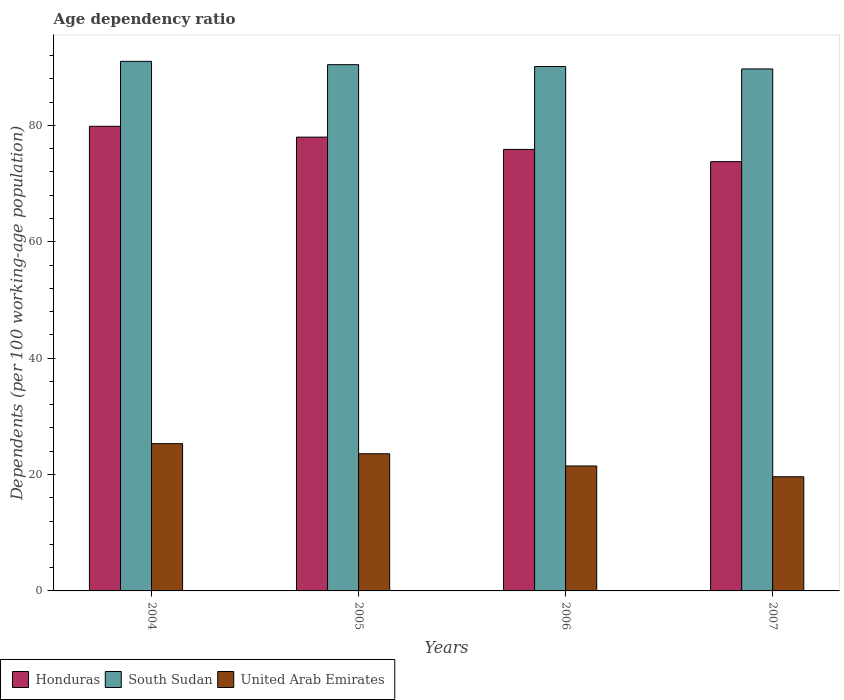How many different coloured bars are there?
Make the answer very short. 3. How many groups of bars are there?
Your answer should be compact. 4. Are the number of bars per tick equal to the number of legend labels?
Your answer should be very brief. Yes. How many bars are there on the 2nd tick from the right?
Keep it short and to the point. 3. What is the age dependency ratio in in Honduras in 2004?
Offer a terse response. 79.83. Across all years, what is the maximum age dependency ratio in in United Arab Emirates?
Ensure brevity in your answer.  25.3. Across all years, what is the minimum age dependency ratio in in South Sudan?
Your answer should be very brief. 89.69. In which year was the age dependency ratio in in Honduras minimum?
Offer a terse response. 2007. What is the total age dependency ratio in in Honduras in the graph?
Your answer should be compact. 307.42. What is the difference between the age dependency ratio in in South Sudan in 2004 and that in 2006?
Your answer should be very brief. 0.89. What is the difference between the age dependency ratio in in South Sudan in 2006 and the age dependency ratio in in United Arab Emirates in 2004?
Provide a succinct answer. 64.8. What is the average age dependency ratio in in United Arab Emirates per year?
Offer a very short reply. 22.49. In the year 2005, what is the difference between the age dependency ratio in in South Sudan and age dependency ratio in in United Arab Emirates?
Keep it short and to the point. 66.86. In how many years, is the age dependency ratio in in United Arab Emirates greater than 44 %?
Offer a very short reply. 0. What is the ratio of the age dependency ratio in in Honduras in 2006 to that in 2007?
Give a very brief answer. 1.03. Is the difference between the age dependency ratio in in South Sudan in 2005 and 2007 greater than the difference between the age dependency ratio in in United Arab Emirates in 2005 and 2007?
Provide a succinct answer. No. What is the difference between the highest and the second highest age dependency ratio in in United Arab Emirates?
Give a very brief answer. 1.74. What is the difference between the highest and the lowest age dependency ratio in in South Sudan?
Keep it short and to the point. 1.3. Is the sum of the age dependency ratio in in South Sudan in 2005 and 2006 greater than the maximum age dependency ratio in in Honduras across all years?
Your answer should be compact. Yes. What does the 3rd bar from the left in 2004 represents?
Provide a short and direct response. United Arab Emirates. What does the 3rd bar from the right in 2007 represents?
Provide a short and direct response. Honduras. How many bars are there?
Your answer should be very brief. 12. Are all the bars in the graph horizontal?
Offer a very short reply. No. Are the values on the major ticks of Y-axis written in scientific E-notation?
Give a very brief answer. No. Does the graph contain any zero values?
Offer a terse response. No. How are the legend labels stacked?
Ensure brevity in your answer.  Horizontal. What is the title of the graph?
Make the answer very short. Age dependency ratio. What is the label or title of the Y-axis?
Give a very brief answer. Dependents (per 100 working-age population). What is the Dependents (per 100 working-age population) in Honduras in 2004?
Your answer should be compact. 79.83. What is the Dependents (per 100 working-age population) in South Sudan in 2004?
Your answer should be very brief. 90.99. What is the Dependents (per 100 working-age population) in United Arab Emirates in 2004?
Provide a succinct answer. 25.3. What is the Dependents (per 100 working-age population) in Honduras in 2005?
Offer a very short reply. 77.97. What is the Dependents (per 100 working-age population) in South Sudan in 2005?
Offer a very short reply. 90.42. What is the Dependents (per 100 working-age population) of United Arab Emirates in 2005?
Provide a succinct answer. 23.57. What is the Dependents (per 100 working-age population) of Honduras in 2006?
Your answer should be compact. 75.86. What is the Dependents (per 100 working-age population) of South Sudan in 2006?
Offer a terse response. 90.1. What is the Dependents (per 100 working-age population) in United Arab Emirates in 2006?
Your answer should be compact. 21.47. What is the Dependents (per 100 working-age population) of Honduras in 2007?
Offer a very short reply. 73.75. What is the Dependents (per 100 working-age population) in South Sudan in 2007?
Offer a very short reply. 89.69. What is the Dependents (per 100 working-age population) in United Arab Emirates in 2007?
Offer a terse response. 19.61. Across all years, what is the maximum Dependents (per 100 working-age population) of Honduras?
Offer a terse response. 79.83. Across all years, what is the maximum Dependents (per 100 working-age population) in South Sudan?
Make the answer very short. 90.99. Across all years, what is the maximum Dependents (per 100 working-age population) of United Arab Emirates?
Offer a terse response. 25.3. Across all years, what is the minimum Dependents (per 100 working-age population) in Honduras?
Your answer should be compact. 73.75. Across all years, what is the minimum Dependents (per 100 working-age population) of South Sudan?
Provide a short and direct response. 89.69. Across all years, what is the minimum Dependents (per 100 working-age population) in United Arab Emirates?
Your response must be concise. 19.61. What is the total Dependents (per 100 working-age population) in Honduras in the graph?
Your response must be concise. 307.42. What is the total Dependents (per 100 working-age population) of South Sudan in the graph?
Offer a terse response. 361.2. What is the total Dependents (per 100 working-age population) of United Arab Emirates in the graph?
Give a very brief answer. 89.95. What is the difference between the Dependents (per 100 working-age population) in Honduras in 2004 and that in 2005?
Provide a succinct answer. 1.86. What is the difference between the Dependents (per 100 working-age population) of South Sudan in 2004 and that in 2005?
Keep it short and to the point. 0.57. What is the difference between the Dependents (per 100 working-age population) of United Arab Emirates in 2004 and that in 2005?
Ensure brevity in your answer.  1.74. What is the difference between the Dependents (per 100 working-age population) in Honduras in 2004 and that in 2006?
Offer a terse response. 3.97. What is the difference between the Dependents (per 100 working-age population) in South Sudan in 2004 and that in 2006?
Offer a very short reply. 0.89. What is the difference between the Dependents (per 100 working-age population) of United Arab Emirates in 2004 and that in 2006?
Keep it short and to the point. 3.84. What is the difference between the Dependents (per 100 working-age population) of Honduras in 2004 and that in 2007?
Offer a terse response. 6.08. What is the difference between the Dependents (per 100 working-age population) of South Sudan in 2004 and that in 2007?
Provide a short and direct response. 1.3. What is the difference between the Dependents (per 100 working-age population) in United Arab Emirates in 2004 and that in 2007?
Provide a succinct answer. 5.69. What is the difference between the Dependents (per 100 working-age population) of Honduras in 2005 and that in 2006?
Ensure brevity in your answer.  2.11. What is the difference between the Dependents (per 100 working-age population) of South Sudan in 2005 and that in 2006?
Your response must be concise. 0.32. What is the difference between the Dependents (per 100 working-age population) in United Arab Emirates in 2005 and that in 2006?
Provide a short and direct response. 2.1. What is the difference between the Dependents (per 100 working-age population) in Honduras in 2005 and that in 2007?
Provide a short and direct response. 4.22. What is the difference between the Dependents (per 100 working-age population) of South Sudan in 2005 and that in 2007?
Make the answer very short. 0.73. What is the difference between the Dependents (per 100 working-age population) of United Arab Emirates in 2005 and that in 2007?
Provide a short and direct response. 3.95. What is the difference between the Dependents (per 100 working-age population) in Honduras in 2006 and that in 2007?
Your response must be concise. 2.11. What is the difference between the Dependents (per 100 working-age population) in South Sudan in 2006 and that in 2007?
Ensure brevity in your answer.  0.42. What is the difference between the Dependents (per 100 working-age population) in United Arab Emirates in 2006 and that in 2007?
Offer a very short reply. 1.85. What is the difference between the Dependents (per 100 working-age population) of Honduras in 2004 and the Dependents (per 100 working-age population) of South Sudan in 2005?
Make the answer very short. -10.59. What is the difference between the Dependents (per 100 working-age population) of Honduras in 2004 and the Dependents (per 100 working-age population) of United Arab Emirates in 2005?
Ensure brevity in your answer.  56.26. What is the difference between the Dependents (per 100 working-age population) in South Sudan in 2004 and the Dependents (per 100 working-age population) in United Arab Emirates in 2005?
Offer a very short reply. 67.43. What is the difference between the Dependents (per 100 working-age population) of Honduras in 2004 and the Dependents (per 100 working-age population) of South Sudan in 2006?
Your response must be concise. -10.27. What is the difference between the Dependents (per 100 working-age population) in Honduras in 2004 and the Dependents (per 100 working-age population) in United Arab Emirates in 2006?
Your response must be concise. 58.36. What is the difference between the Dependents (per 100 working-age population) of South Sudan in 2004 and the Dependents (per 100 working-age population) of United Arab Emirates in 2006?
Your response must be concise. 69.52. What is the difference between the Dependents (per 100 working-age population) of Honduras in 2004 and the Dependents (per 100 working-age population) of South Sudan in 2007?
Your response must be concise. -9.86. What is the difference between the Dependents (per 100 working-age population) of Honduras in 2004 and the Dependents (per 100 working-age population) of United Arab Emirates in 2007?
Your response must be concise. 60.22. What is the difference between the Dependents (per 100 working-age population) of South Sudan in 2004 and the Dependents (per 100 working-age population) of United Arab Emirates in 2007?
Your answer should be compact. 71.38. What is the difference between the Dependents (per 100 working-age population) in Honduras in 2005 and the Dependents (per 100 working-age population) in South Sudan in 2006?
Your answer should be very brief. -12.13. What is the difference between the Dependents (per 100 working-age population) in Honduras in 2005 and the Dependents (per 100 working-age population) in United Arab Emirates in 2006?
Give a very brief answer. 56.5. What is the difference between the Dependents (per 100 working-age population) in South Sudan in 2005 and the Dependents (per 100 working-age population) in United Arab Emirates in 2006?
Keep it short and to the point. 68.95. What is the difference between the Dependents (per 100 working-age population) of Honduras in 2005 and the Dependents (per 100 working-age population) of South Sudan in 2007?
Ensure brevity in your answer.  -11.72. What is the difference between the Dependents (per 100 working-age population) of Honduras in 2005 and the Dependents (per 100 working-age population) of United Arab Emirates in 2007?
Your response must be concise. 58.36. What is the difference between the Dependents (per 100 working-age population) in South Sudan in 2005 and the Dependents (per 100 working-age population) in United Arab Emirates in 2007?
Your response must be concise. 70.81. What is the difference between the Dependents (per 100 working-age population) in Honduras in 2006 and the Dependents (per 100 working-age population) in South Sudan in 2007?
Your answer should be compact. -13.83. What is the difference between the Dependents (per 100 working-age population) in Honduras in 2006 and the Dependents (per 100 working-age population) in United Arab Emirates in 2007?
Offer a very short reply. 56.25. What is the difference between the Dependents (per 100 working-age population) in South Sudan in 2006 and the Dependents (per 100 working-age population) in United Arab Emirates in 2007?
Offer a terse response. 70.49. What is the average Dependents (per 100 working-age population) of Honduras per year?
Your answer should be very brief. 76.85. What is the average Dependents (per 100 working-age population) in South Sudan per year?
Offer a terse response. 90.3. What is the average Dependents (per 100 working-age population) of United Arab Emirates per year?
Your response must be concise. 22.49. In the year 2004, what is the difference between the Dependents (per 100 working-age population) of Honduras and Dependents (per 100 working-age population) of South Sudan?
Offer a very short reply. -11.16. In the year 2004, what is the difference between the Dependents (per 100 working-age population) of Honduras and Dependents (per 100 working-age population) of United Arab Emirates?
Your response must be concise. 54.53. In the year 2004, what is the difference between the Dependents (per 100 working-age population) in South Sudan and Dependents (per 100 working-age population) in United Arab Emirates?
Provide a short and direct response. 65.69. In the year 2005, what is the difference between the Dependents (per 100 working-age population) of Honduras and Dependents (per 100 working-age population) of South Sudan?
Make the answer very short. -12.45. In the year 2005, what is the difference between the Dependents (per 100 working-age population) of Honduras and Dependents (per 100 working-age population) of United Arab Emirates?
Your answer should be compact. 54.4. In the year 2005, what is the difference between the Dependents (per 100 working-age population) of South Sudan and Dependents (per 100 working-age population) of United Arab Emirates?
Provide a short and direct response. 66.86. In the year 2006, what is the difference between the Dependents (per 100 working-age population) in Honduras and Dependents (per 100 working-age population) in South Sudan?
Provide a succinct answer. -14.24. In the year 2006, what is the difference between the Dependents (per 100 working-age population) of Honduras and Dependents (per 100 working-age population) of United Arab Emirates?
Make the answer very short. 54.39. In the year 2006, what is the difference between the Dependents (per 100 working-age population) in South Sudan and Dependents (per 100 working-age population) in United Arab Emirates?
Give a very brief answer. 68.64. In the year 2007, what is the difference between the Dependents (per 100 working-age population) of Honduras and Dependents (per 100 working-age population) of South Sudan?
Ensure brevity in your answer.  -15.93. In the year 2007, what is the difference between the Dependents (per 100 working-age population) in Honduras and Dependents (per 100 working-age population) in United Arab Emirates?
Your answer should be compact. 54.14. In the year 2007, what is the difference between the Dependents (per 100 working-age population) of South Sudan and Dependents (per 100 working-age population) of United Arab Emirates?
Ensure brevity in your answer.  70.07. What is the ratio of the Dependents (per 100 working-age population) of Honduras in 2004 to that in 2005?
Your answer should be very brief. 1.02. What is the ratio of the Dependents (per 100 working-age population) of South Sudan in 2004 to that in 2005?
Offer a very short reply. 1.01. What is the ratio of the Dependents (per 100 working-age population) in United Arab Emirates in 2004 to that in 2005?
Your response must be concise. 1.07. What is the ratio of the Dependents (per 100 working-age population) in Honduras in 2004 to that in 2006?
Your response must be concise. 1.05. What is the ratio of the Dependents (per 100 working-age population) of South Sudan in 2004 to that in 2006?
Your answer should be very brief. 1.01. What is the ratio of the Dependents (per 100 working-age population) in United Arab Emirates in 2004 to that in 2006?
Your answer should be compact. 1.18. What is the ratio of the Dependents (per 100 working-age population) in Honduras in 2004 to that in 2007?
Provide a short and direct response. 1.08. What is the ratio of the Dependents (per 100 working-age population) of South Sudan in 2004 to that in 2007?
Make the answer very short. 1.01. What is the ratio of the Dependents (per 100 working-age population) in United Arab Emirates in 2004 to that in 2007?
Keep it short and to the point. 1.29. What is the ratio of the Dependents (per 100 working-age population) in Honduras in 2005 to that in 2006?
Your answer should be very brief. 1.03. What is the ratio of the Dependents (per 100 working-age population) of United Arab Emirates in 2005 to that in 2006?
Offer a terse response. 1.1. What is the ratio of the Dependents (per 100 working-age population) of Honduras in 2005 to that in 2007?
Ensure brevity in your answer.  1.06. What is the ratio of the Dependents (per 100 working-age population) of South Sudan in 2005 to that in 2007?
Your response must be concise. 1.01. What is the ratio of the Dependents (per 100 working-age population) in United Arab Emirates in 2005 to that in 2007?
Make the answer very short. 1.2. What is the ratio of the Dependents (per 100 working-age population) of Honduras in 2006 to that in 2007?
Offer a very short reply. 1.03. What is the ratio of the Dependents (per 100 working-age population) in South Sudan in 2006 to that in 2007?
Keep it short and to the point. 1. What is the ratio of the Dependents (per 100 working-age population) of United Arab Emirates in 2006 to that in 2007?
Keep it short and to the point. 1.09. What is the difference between the highest and the second highest Dependents (per 100 working-age population) of Honduras?
Offer a very short reply. 1.86. What is the difference between the highest and the second highest Dependents (per 100 working-age population) in South Sudan?
Keep it short and to the point. 0.57. What is the difference between the highest and the second highest Dependents (per 100 working-age population) in United Arab Emirates?
Offer a terse response. 1.74. What is the difference between the highest and the lowest Dependents (per 100 working-age population) of Honduras?
Ensure brevity in your answer.  6.08. What is the difference between the highest and the lowest Dependents (per 100 working-age population) of South Sudan?
Offer a terse response. 1.3. What is the difference between the highest and the lowest Dependents (per 100 working-age population) in United Arab Emirates?
Your response must be concise. 5.69. 